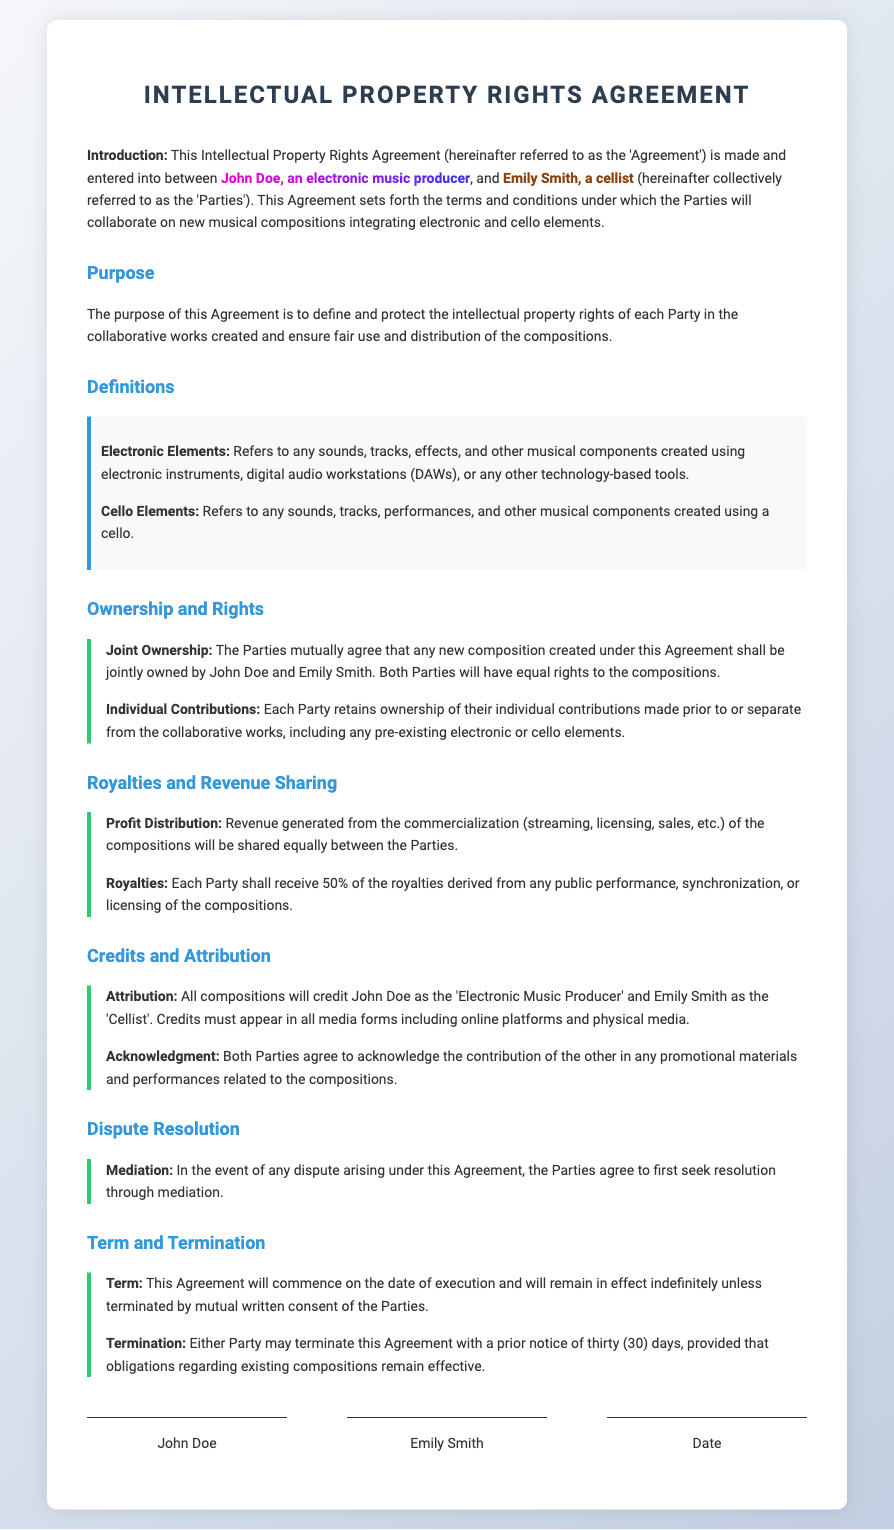What is the title of the agreement? The title of the document is mentioned at the top, providing an overview of its content.
Answer: Intellectual Property Rights Agreement Who are the parties involved in the agreement? The Parties are explicitly named in the introduction of the document.
Answer: John Doe and Emily Smith What is the profit distribution percentage for each party? The document states how the revenue will be shared between the parties.
Answer: 50% What must be credited in all media forms? The document specifies what contributions should be acknowledged in various media forms.
Answer: John Doe as the 'Electronic Music Producer' and Emily Smith as the 'Cellist' What is the initial step for dispute resolution? The document outlines the first action the parties should take in case of a disagreement.
Answer: Mediation What is the term of the agreement? The document specifies when the agreement will start and its duration.
Answer: Indefinitely How long is the notice period for termination? The document indicates the required notice period for either party to terminate the agreement.
Answer: Thirty (30) days What type of elements are considered "Electronic Elements"? The document defines what constitutes electronic components in the compositions.
Answer: Sounds, tracks, effects, and other musical components created using electronic instruments What type of ownership is declared for new compositions? The agreement specifies the ownership rights concerning the new musical compositions produced.
Answer: Joint Ownership 